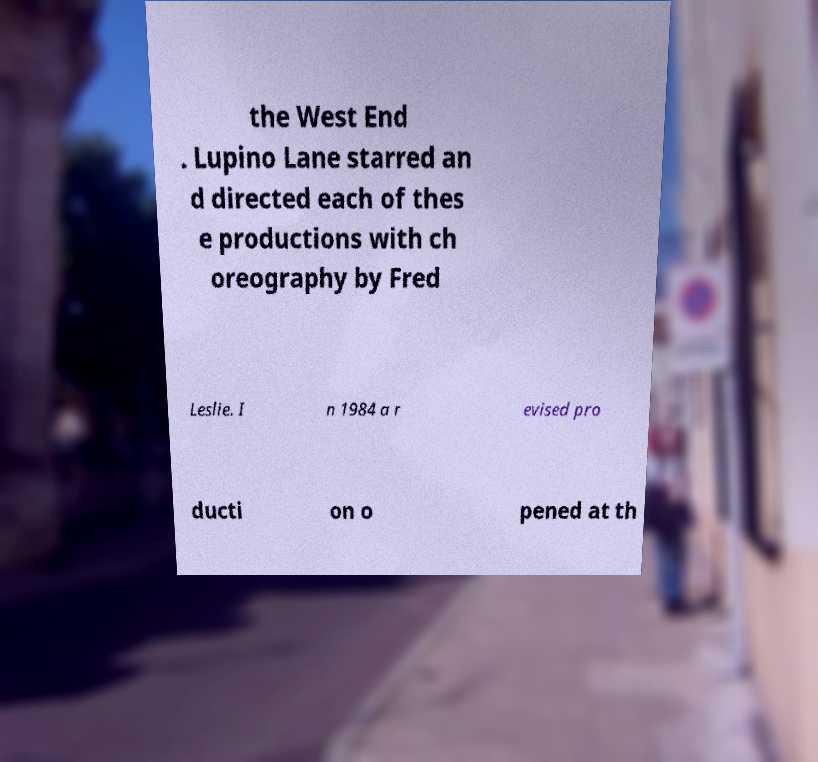Please read and relay the text visible in this image. What does it say? the West End . Lupino Lane starred an d directed each of thes e productions with ch oreography by Fred Leslie. I n 1984 a r evised pro ducti on o pened at th 